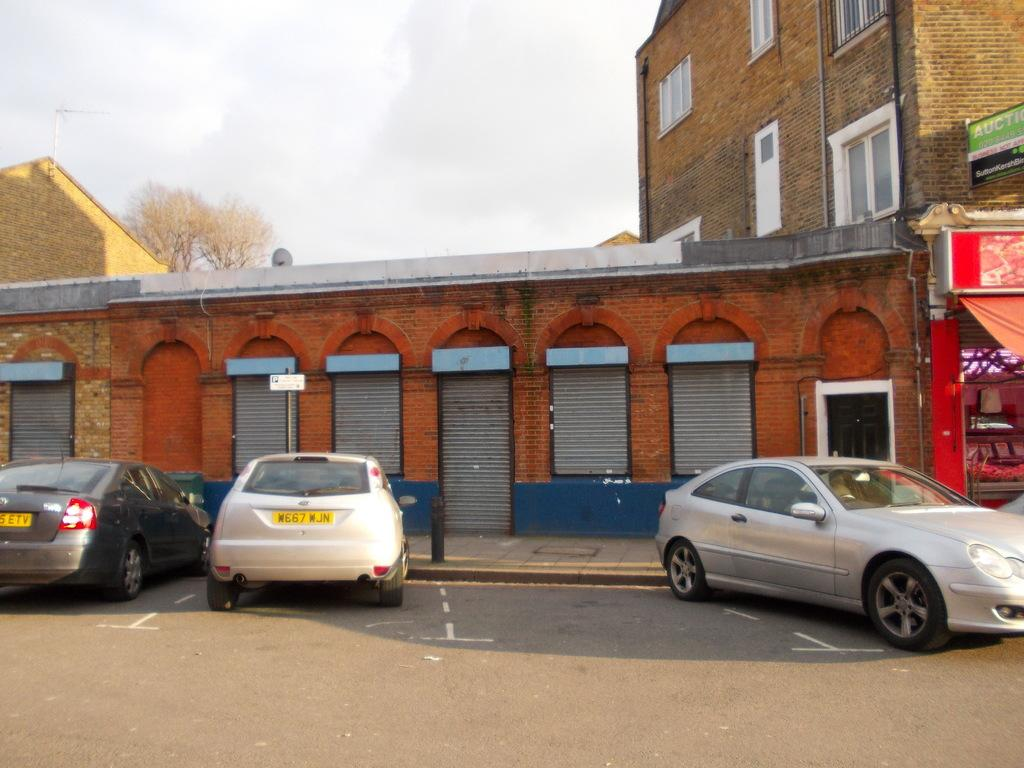What can be seen on the road in the image? There are cars on the road in the image. What is the tall, vertical object in the image? There is a pole in the image. What type of structure is present in the image? There is a building with shutters and windows in the image. What are the signs that can be seen in the image? There are sign boards in the image. What type of vegetation is present in the image? There are trees in the image. What is visible in the sky in the image? The sky is visible in the image and appears cloudy. What is the tendency of the knee in the image? There is no knee present in the image. What type of box can be seen in the image? There is no box present in the image. 